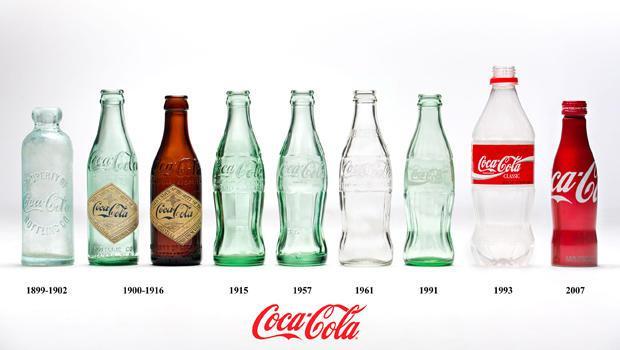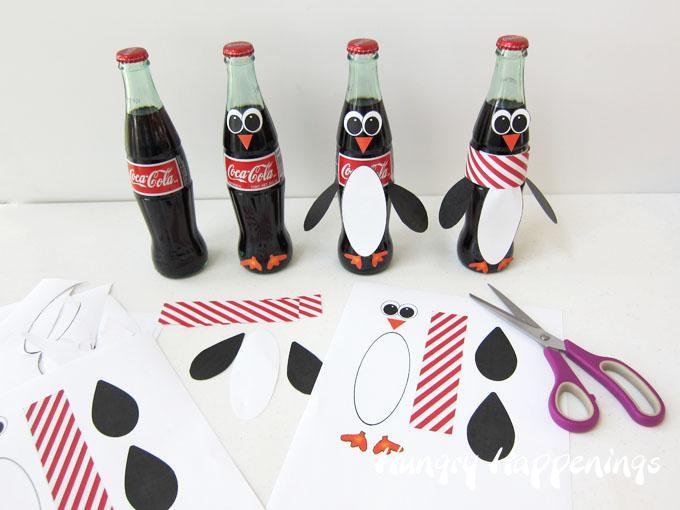The first image is the image on the left, the second image is the image on the right. For the images shown, is this caption "There is no more than three bottles in the right image." true? Answer yes or no. No. 